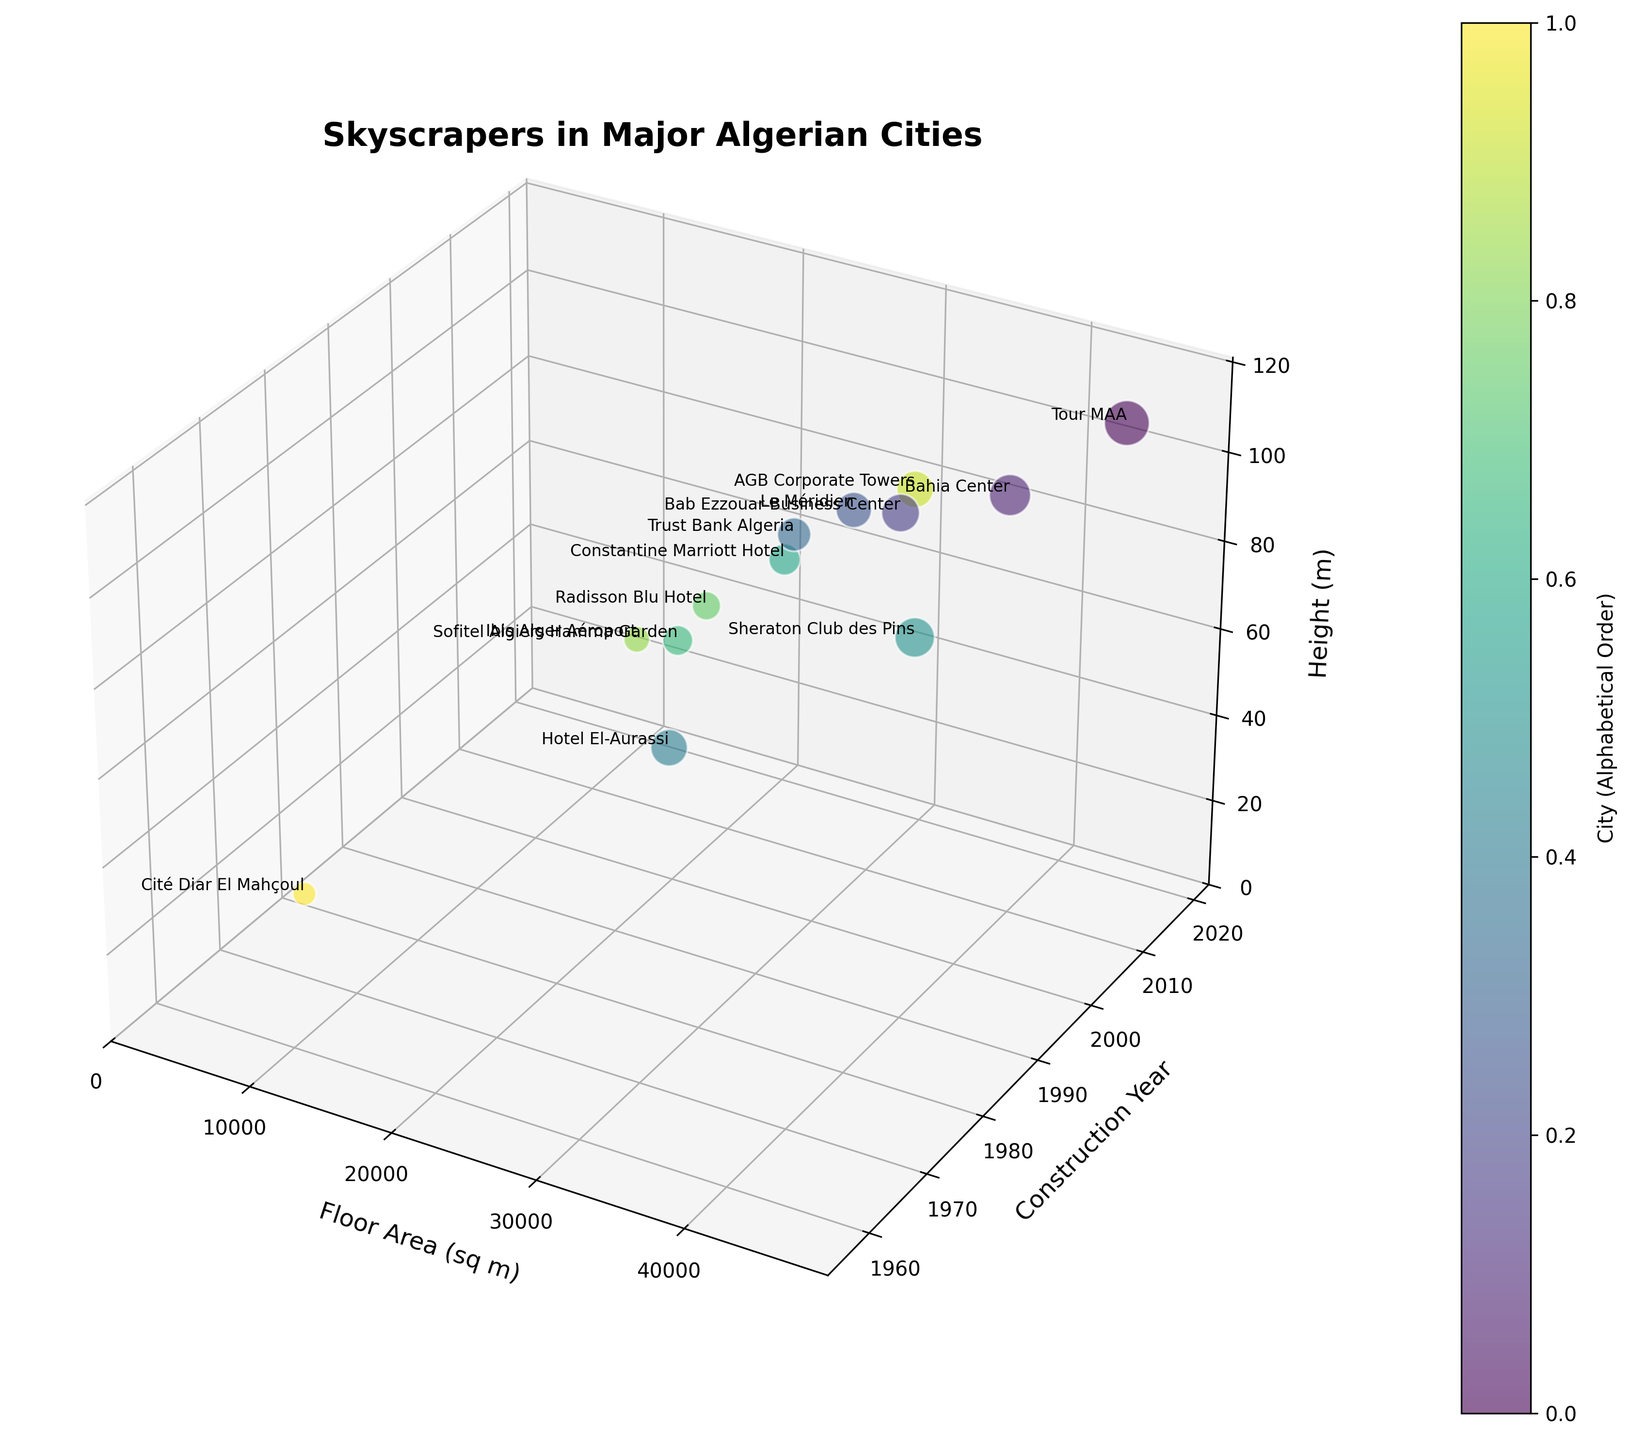What's the tallest building in the figure? To find the tallest building, we look at the highest point along the Z-axis (Height). The tallest building is labeled as "Tour MAA," which has a height of 110 meters.
Answer: Tour MAA Which building has the largest floor area and what is it? To identify the building with the largest floor area, we examine the X-axis (Floor Area). The data point furthest to the right on this axis is labeled "Tour MAA," with a floor area of 45,000 square meters.
Answer: Tour MAA, 45,000 sq m What is the average height of the buildings constructed after 2010? To calculate the average height of buildings constructed after 2010, we look at points with Y-values (Construction Year) greater than 2010. These buildings are Tour MAA, Bahia Center, Le Méridien, Constantine Marriott Hotel, and AGB Corporate Towers. Their heights are 110, 90, 80, 60, 80 meters respectively. The sum of these heights is 420 meters, and there are 5 buildings, so the average is 420/5.
Answer: 84 meters Which city has the most buildings represented in the figure? The city with the most buildings can be determined by the number of data point labels corresponding to each city. Counting the labels, Algiers appears the most frequently with eight buildings.
Answer: Algiers Between "Sheraton Club des Pins" and "Radisson Blu Hotel," which one was constructed first and what are their heights? We compare the Y-values (Construction Year) for both data points. Sheraton Club des Pins was constructed in 2005, and Radisson Blu Hotel was constructed in 2011. We then check their heights on the Z-axis: Sheraton Club des Pins is 65 meters, and Radisson Blu Hotel is 50 meters.
Answer: Sheraton Club des Pins, 65m, 50m Are there any buildings completed before 2000 that have a floor area greater than 25,000 square meters? To find such buildings, we look at data points with a Y-value (Construction Year) less than 2000 and check their X-values (Floor Area). Hotel El-Aurassi, constructed in 1975, has a floor area of 30,000 square meters.
Answer: Yes, Hotel El-Aurassi What is the color coding representing in the figure? The colors in the plot are used to differentiate the skyscrapers based on their cities. Each city is assigned a unique color from the color map to help distinguish between the different data points visually.
Answer: Cities Which is the most recently constructed building and what is its floor area? The most recently constructed building is found by identifying the highest Y-value (Construction Year), which is 2018. The building is "AGB Corporate Towers," with a floor area of 30,000 square meters.
Answer: AGB Corporate Towers, 30,000 sq m How does the height of "Cité Diar El Mahçoul" compare to "Ibis Alger Aéroport"? We compare the Z-values (Height) for both buildings. Cité Diar El Mahçoul has a height of 40 meters, and Ibis Alger Aéroport has a height of 45 meters. Therefore, Ibis Alger Aéroport is taller by 5 meters.
Answer: Ibis Alger Aéroport is taller Which building has the smallest floor area and when was it constructed? The building with the smallest floor area is found by looking at the point closest to zero on the X-axis (Floor Area), which is labeled "Cité Diar El Mahçoul" with a floor area of 12,000 square meters and constructed in 1958.
Answer: Cité Diar El Mahçoul, 1958 